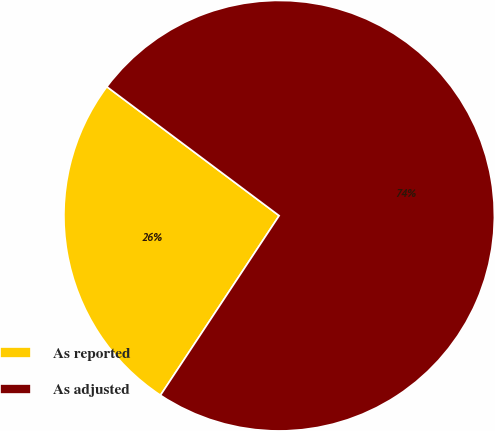<chart> <loc_0><loc_0><loc_500><loc_500><pie_chart><fcel>As reported<fcel>As adjusted<nl><fcel>25.93%<fcel>74.07%<nl></chart> 